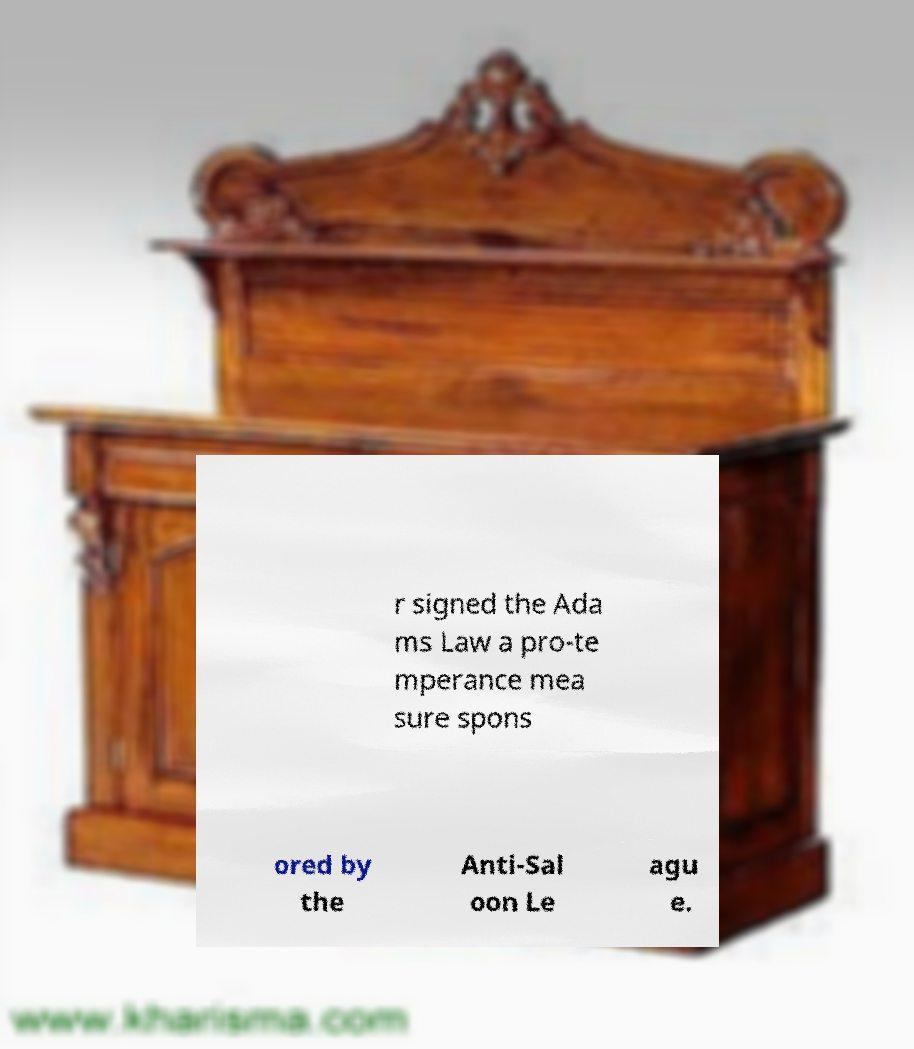For documentation purposes, I need the text within this image transcribed. Could you provide that? r signed the Ada ms Law a pro-te mperance mea sure spons ored by the Anti-Sal oon Le agu e. 